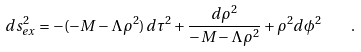<formula> <loc_0><loc_0><loc_500><loc_500>d s ^ { 2 } _ { e x } = - ( - M - \Lambda \rho ^ { 2 } ) \, d \tau ^ { 2 } + \frac { d \rho ^ { 2 } } { - M - \Lambda \rho ^ { 2 } } + \rho ^ { 2 } d \phi ^ { 2 } \quad .</formula> 